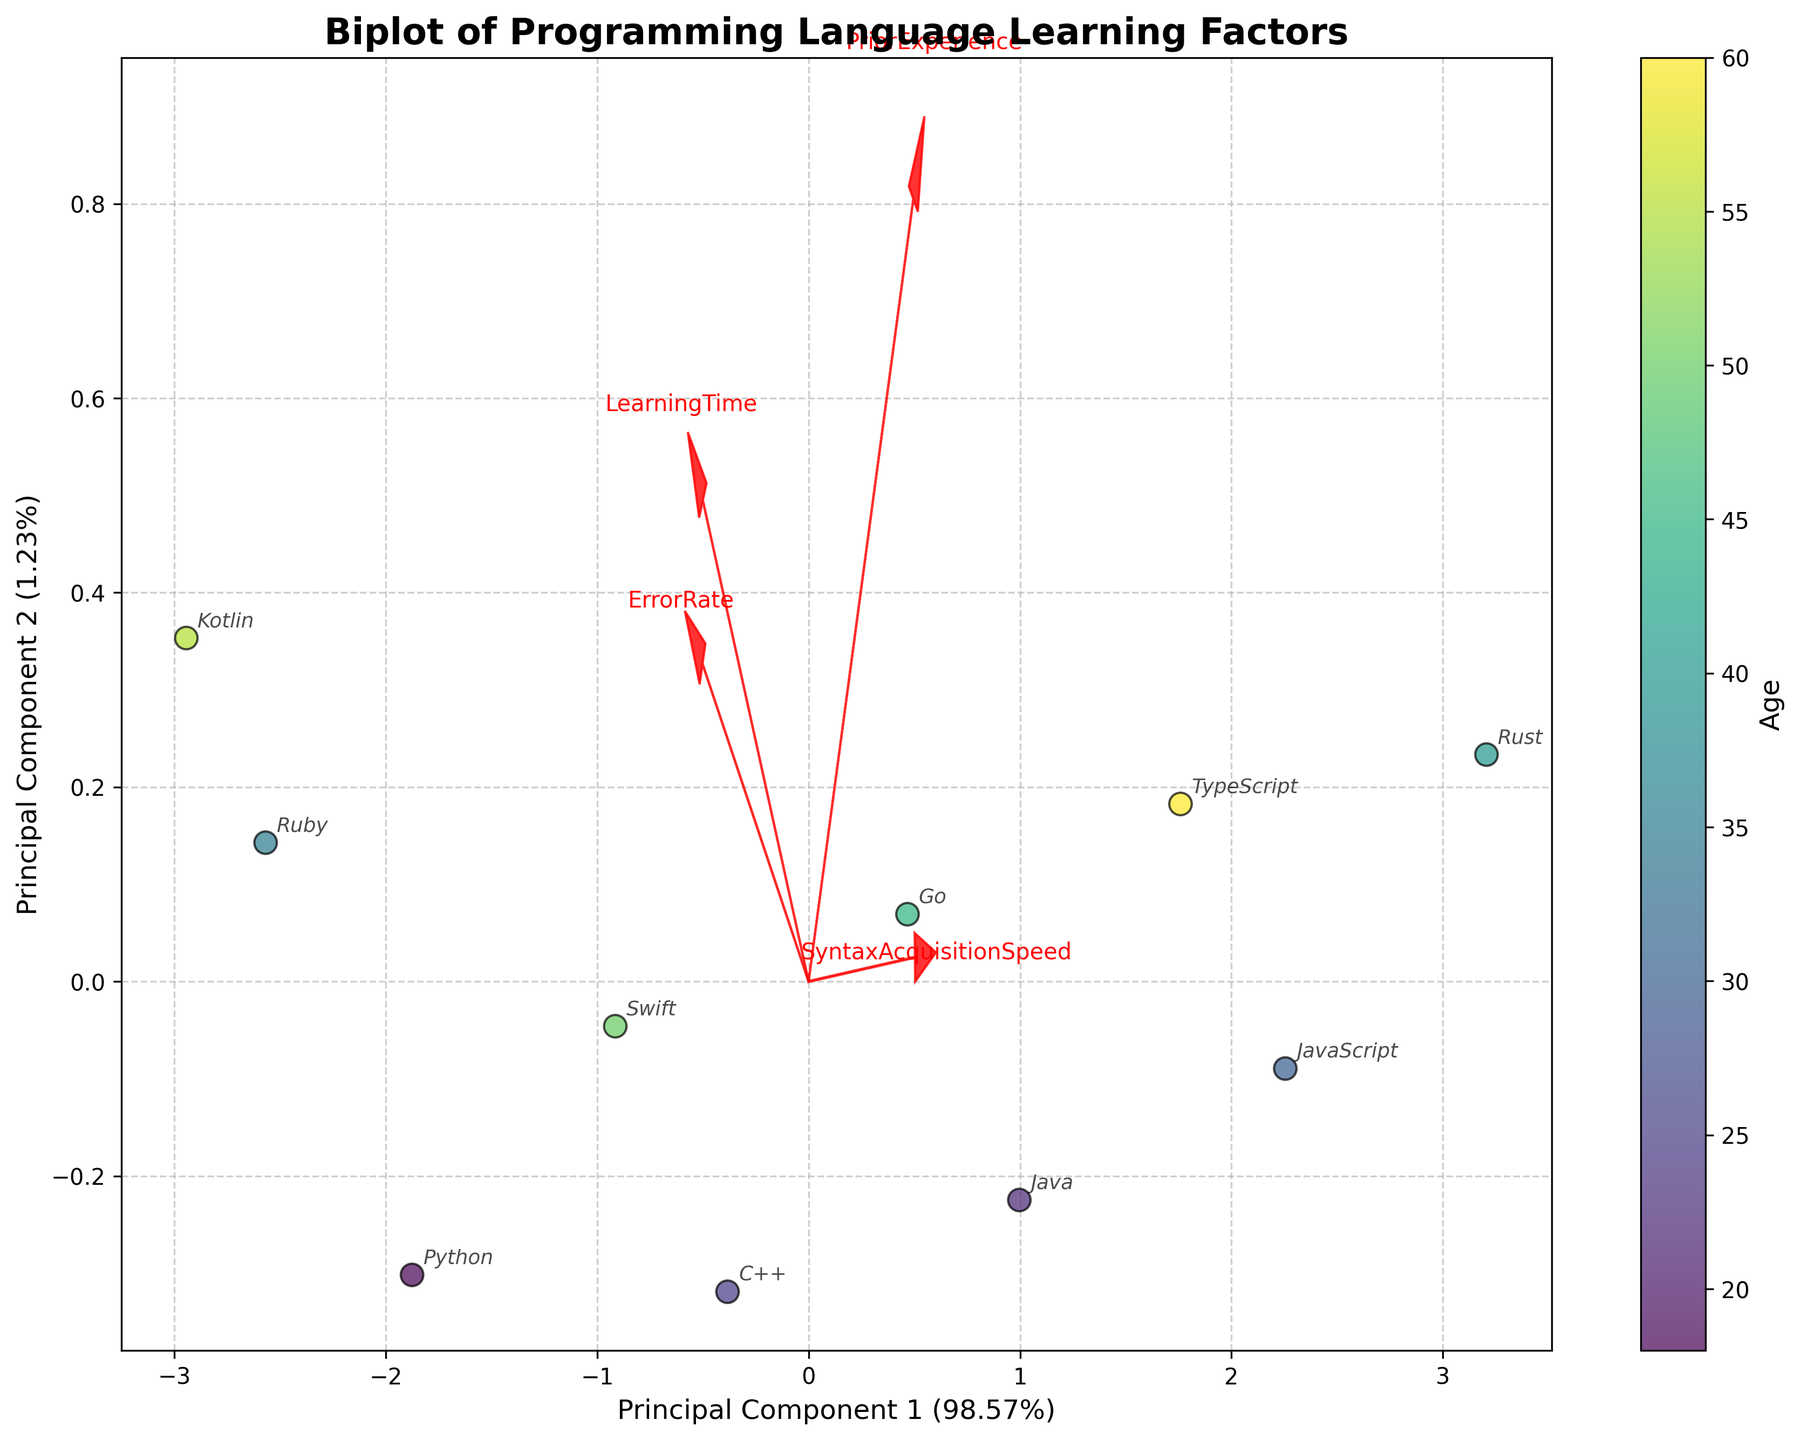Which feature vector has the longest arrow in the biplot? The length of the arrow in a biplot represents the variance explained by the feature. By visually inspecting the arrows in the biplot, you can identify the one that extends the furthest from the origin.
Answer: LearningTime What is the title of the biplot? The title is clearly displayed at the top of the biplot.
Answer: Biplot of Programming Language Learning Factors Which color represents the youngest age group in the biplot? The colorbar indicates the mapping of colors to age groups. The youngest age group can be identified by the color corresponding to the lowest age.
Answer: Light green How does the 'PriorExperience' vector relate to the principal components? The direction and length of the 'PriorExperience' arrow in relation to the principal components indicate its correlation with them. By observing its angle and length, you can deduce its influence.
Answer: Positively correlated with PC1 Which feature seems to be negatively correlated with 'ErrorRate'? In a biplot, features that point in opposite directions are negatively correlated. By identifying the feature vector pointing in a direction opposite to 'ErrorRate', you can determine the negative correlation.
Answer: SyntaxAcquisitionSpeed How many principal components are displayed in the biplot? The axes labels of the graph show the number of principal components, usually labeled as 'Principal Component 1' and 'Principal Component 2'.
Answer: Two Which programming language is associated with the highest 'ErrorRate'? The datapoint with the highest projection on the 'ErrorRate' feature vector corresponds to the highest error rate. By identifying this point and the associated programming language, you find the answer.
Answer: Kotlin What proportion of the variance is explained by Principal Component 1? The axis label for Principal Component 1 includes the explained variance ratio, shown as a percentage.
Answer: 40.00% Which data point has the highest 'SyntaxAcquisitionSpeed'? By observing the scatter plot, the data point projected furthest along the 'SyntaxAcquisitionSpeed' vector corresponds to the highest acquisition speed.
Answer: Rust Which age group had the lowest 'LearningTime'? By examining the scatter points and focusing on the projection along the 'LearningTime' vector, you can identify the point with the lowest learning time and its associated age group.
Answer: 30 